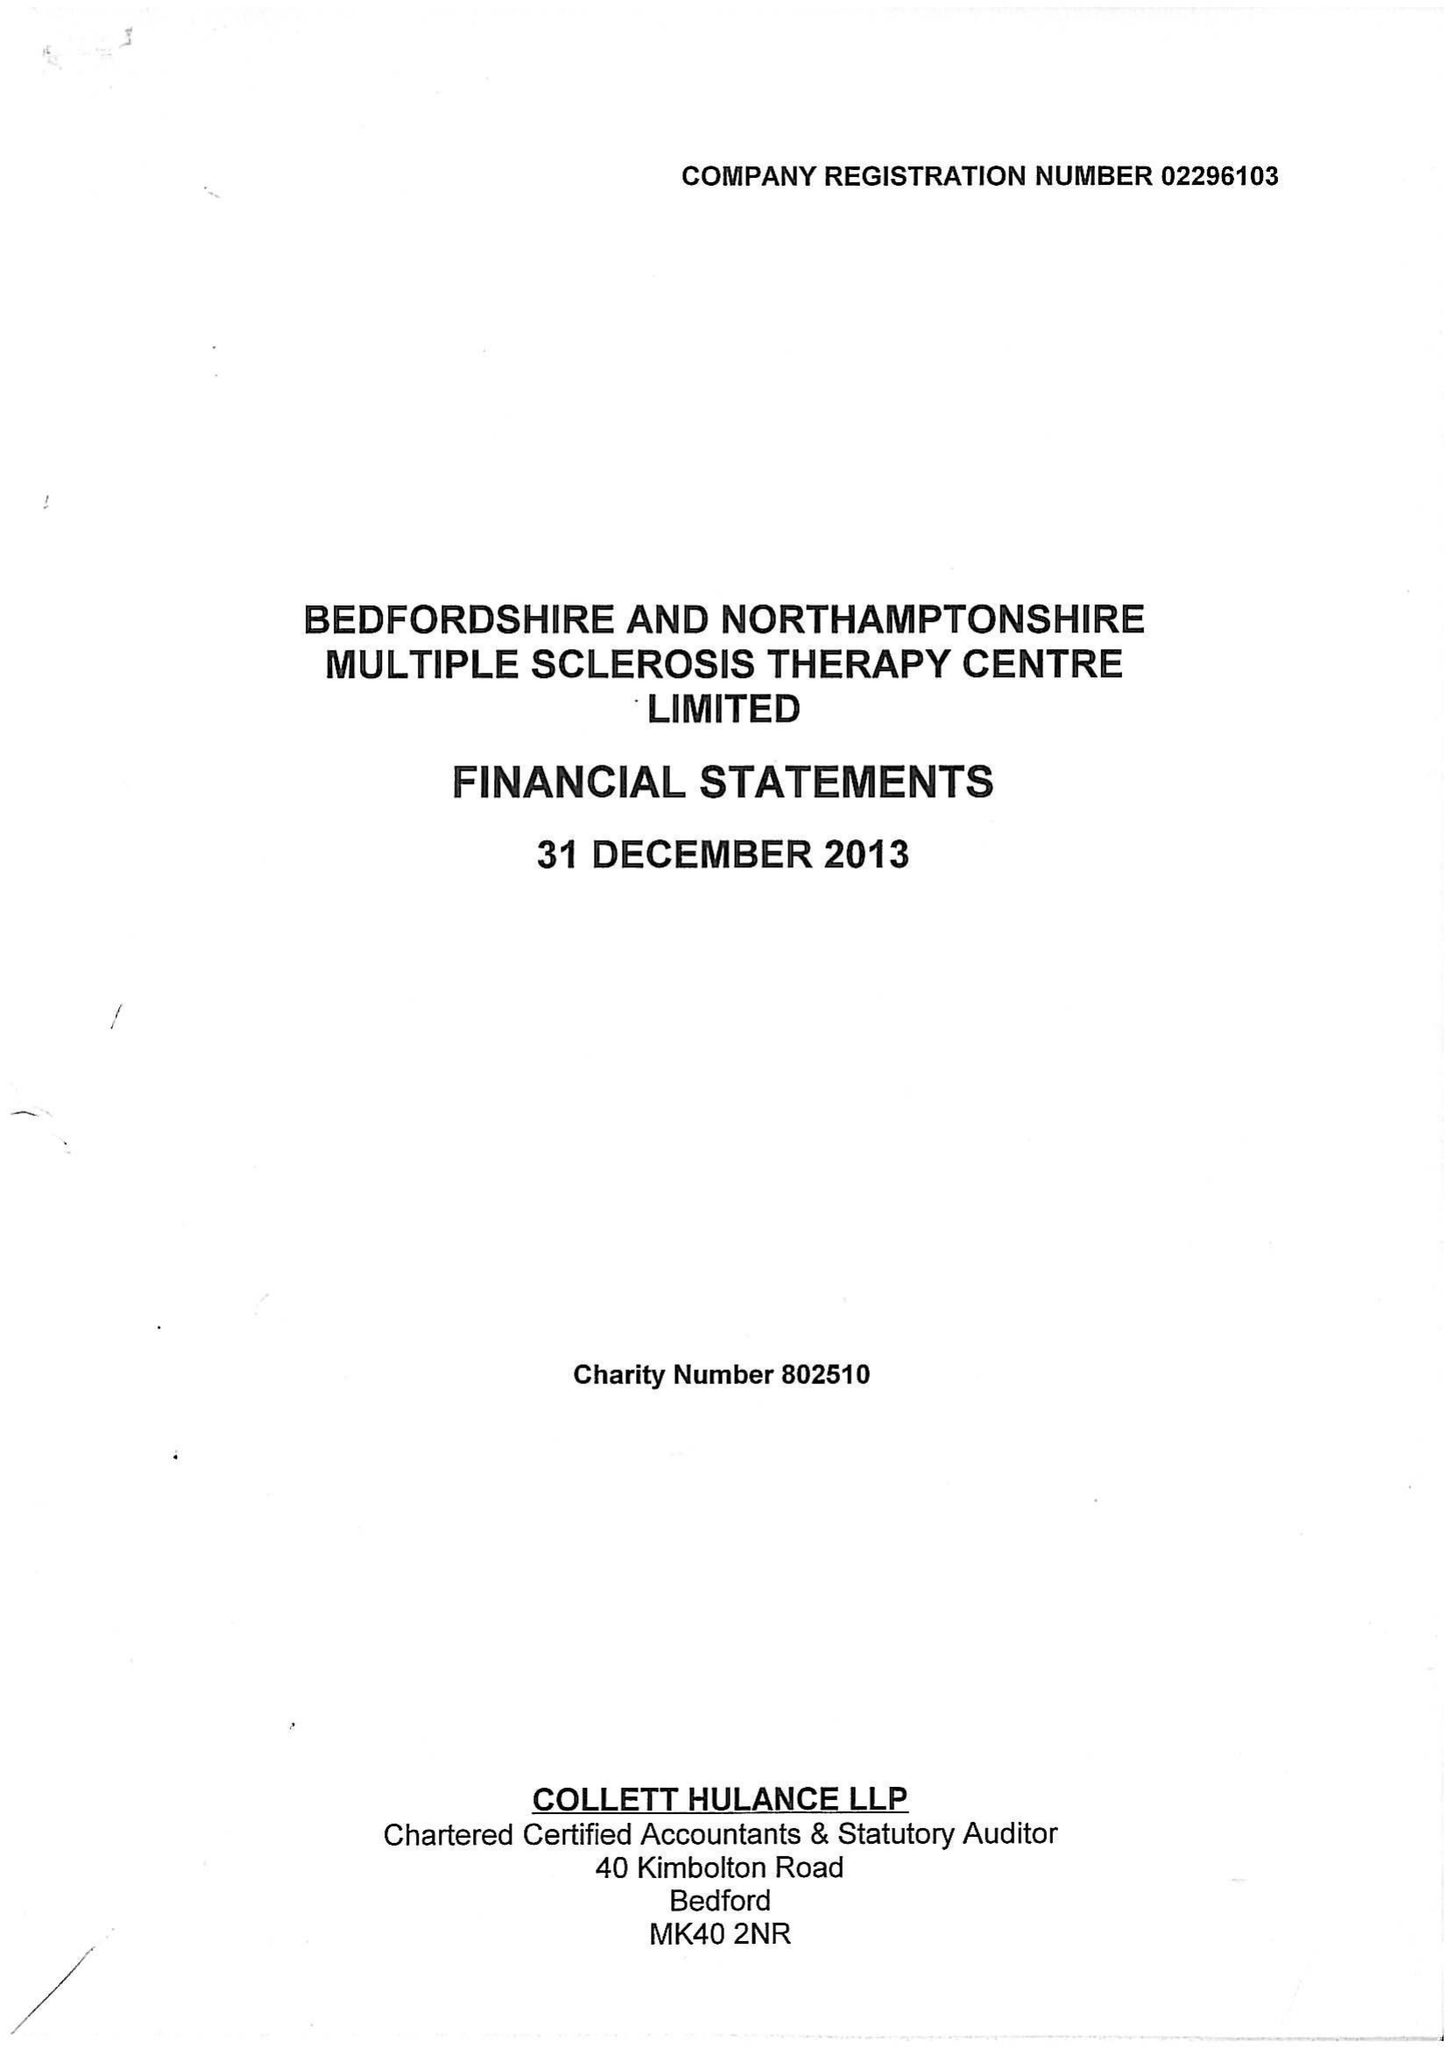What is the value for the charity_number?
Answer the question using a single word or phrase. 802510 